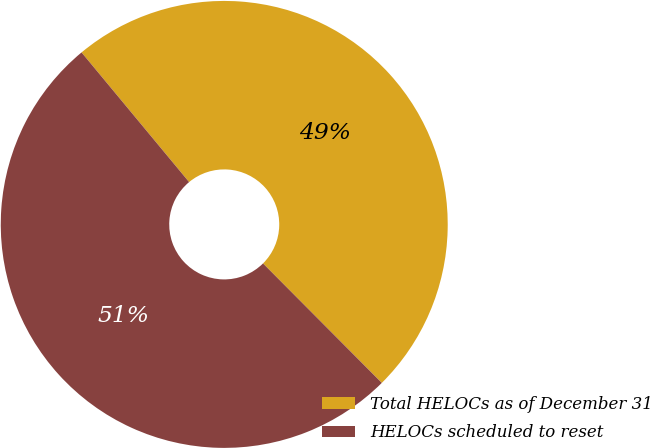Convert chart. <chart><loc_0><loc_0><loc_500><loc_500><pie_chart><fcel>Total HELOCs as of December 31<fcel>HELOCs scheduled to reset<nl><fcel>48.57%<fcel>51.43%<nl></chart> 